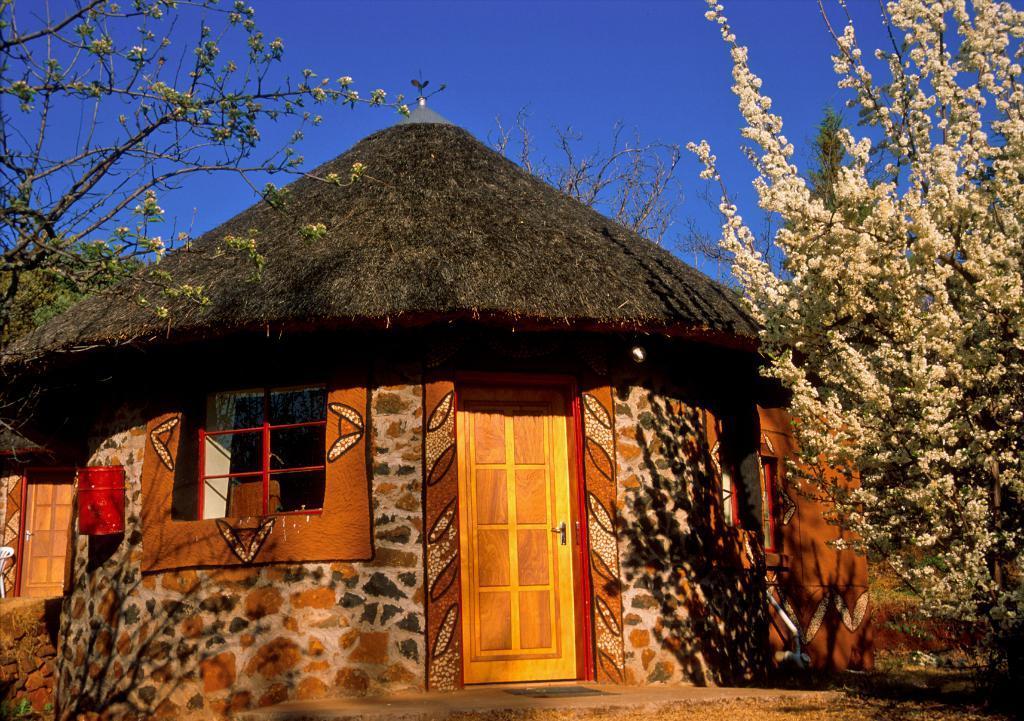How would you summarize this image in a sentence or two? In this image I can see there is a hut, there are few trees on the left and right sides and the sky is clear. 